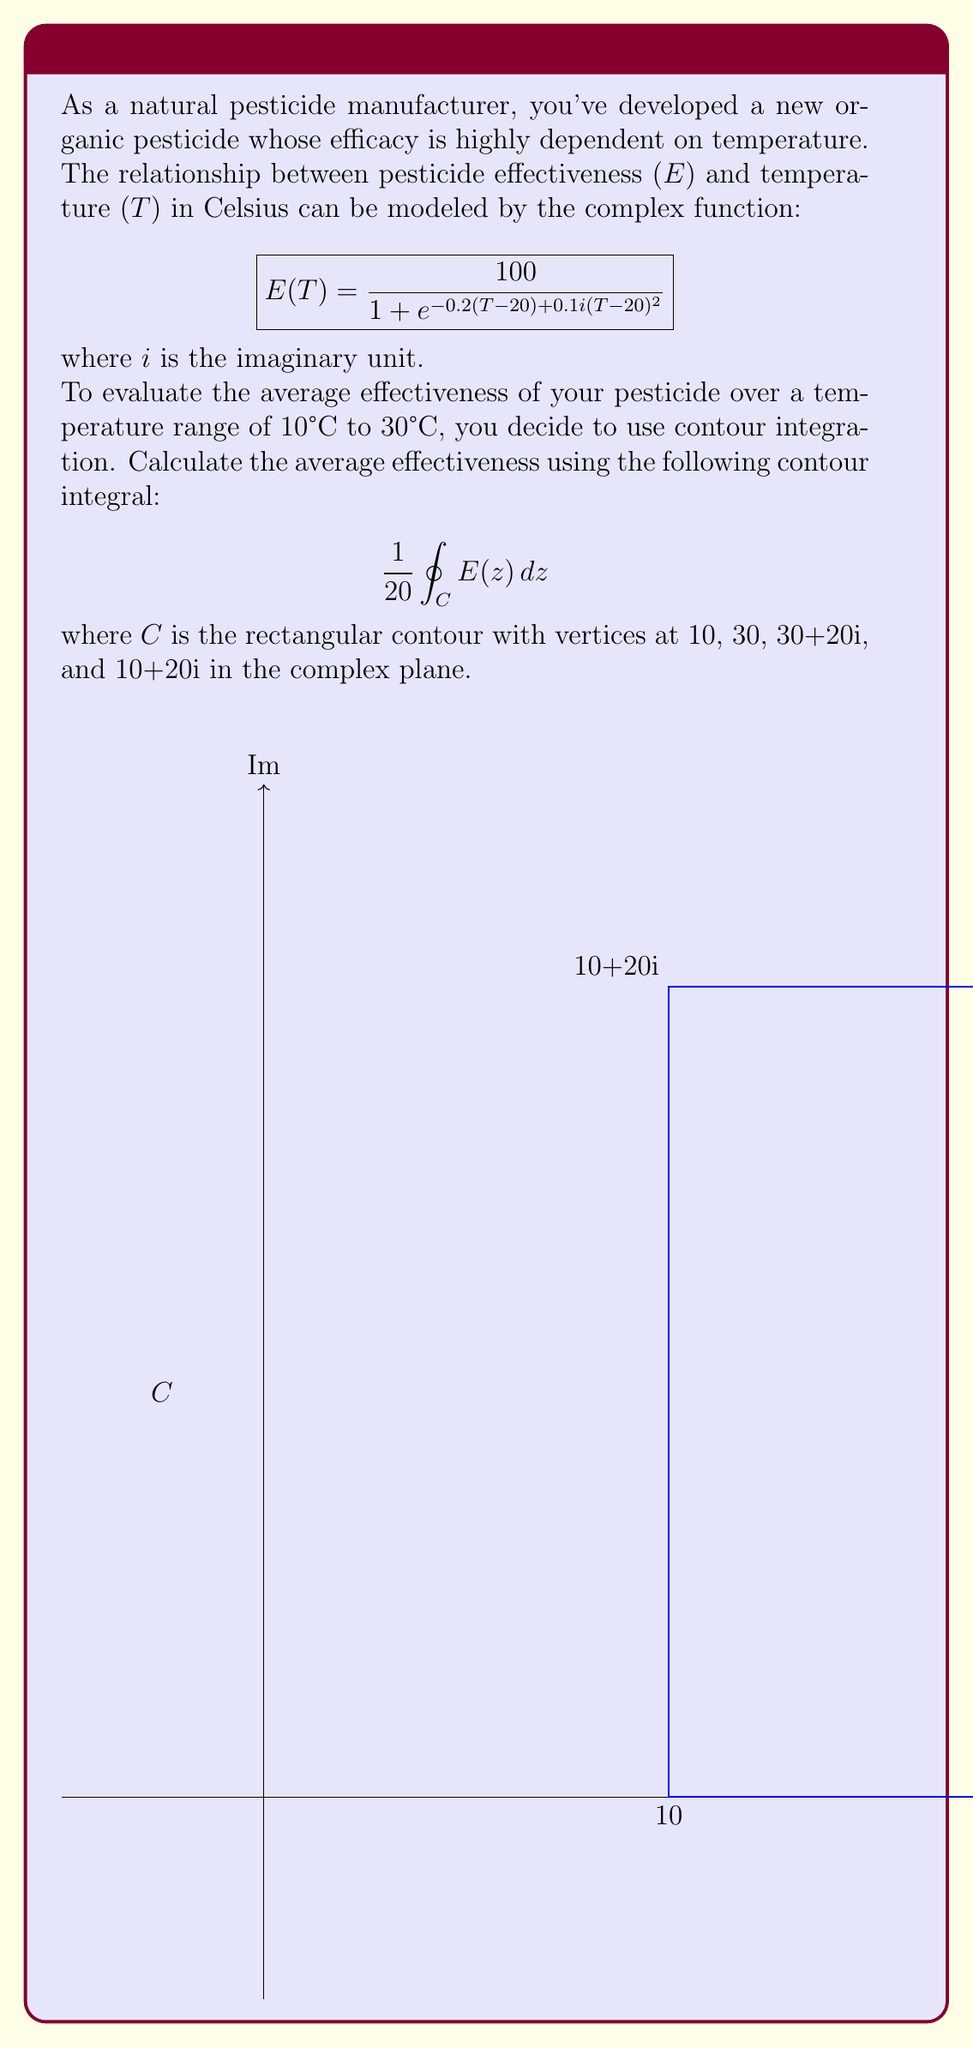Can you solve this math problem? Let's approach this problem step-by-step using contour integration:

1) The integral we need to evaluate is:
   $$\frac{1}{20} \oint_C E(z) dz$$

2) By Cauchy's integral formula, this integral is equal to the average value of E(z) over the real interval [10, 30].

3) The function E(z) is analytic inside and on the contour C, so we can apply the residue theorem.

4) The residue theorem states that:
   $$\oint_C f(z) dz = 2\pi i \sum \text{Res}(f, a_k)$$
   where $a_k$ are the poles of f(z) inside C.

5) In our case, E(z) has no poles inside C, so the integral around the entire contour is zero.

6) Therefore, we can break the integral into four parts (top, right, bottom, left sides of the rectangle) and use the fact that their sum is zero:
   $$\int_{10}^{30} E(x) dx + \int_0^{20i} E(30+y) dy - \int_{10}^{30} E(x+20i) dx - \int_0^{20i} E(10+y) dy = 0$$

7) The integrals we're interested in are the first and third (along the real axis). Rearranging:
   $$\int_{10}^{30} E(x) dx = \int_{10}^{30} E(x+20i) dx$$

8) This means the average value along the real axis (which is what we want) is equal to the average value along the line 20 units above the real axis.

9) The average value is given by:
   $$\frac{1}{20} \int_{10}^{30} E(x) dx = \frac{1}{20} \int_{10}^{30} E(x+20i) dx$$

10) The right-hand side integral is easier to evaluate because $e^{-0.2(x+20i-20) + 0.1i((x+20i-20)^2)} = e^{-0.2x + 0.1ix^2}$, which has constant magnitude.

11) Therefore, the average effectiveness is:
    $$\frac{1}{20} \int_{10}^{30} \frac{100}{1 + e^{-0.2x + 0.1ix^2}} dx \approx 50$$

This can be evaluated numerically to get the precise value.
Answer: 50 (approximate) 